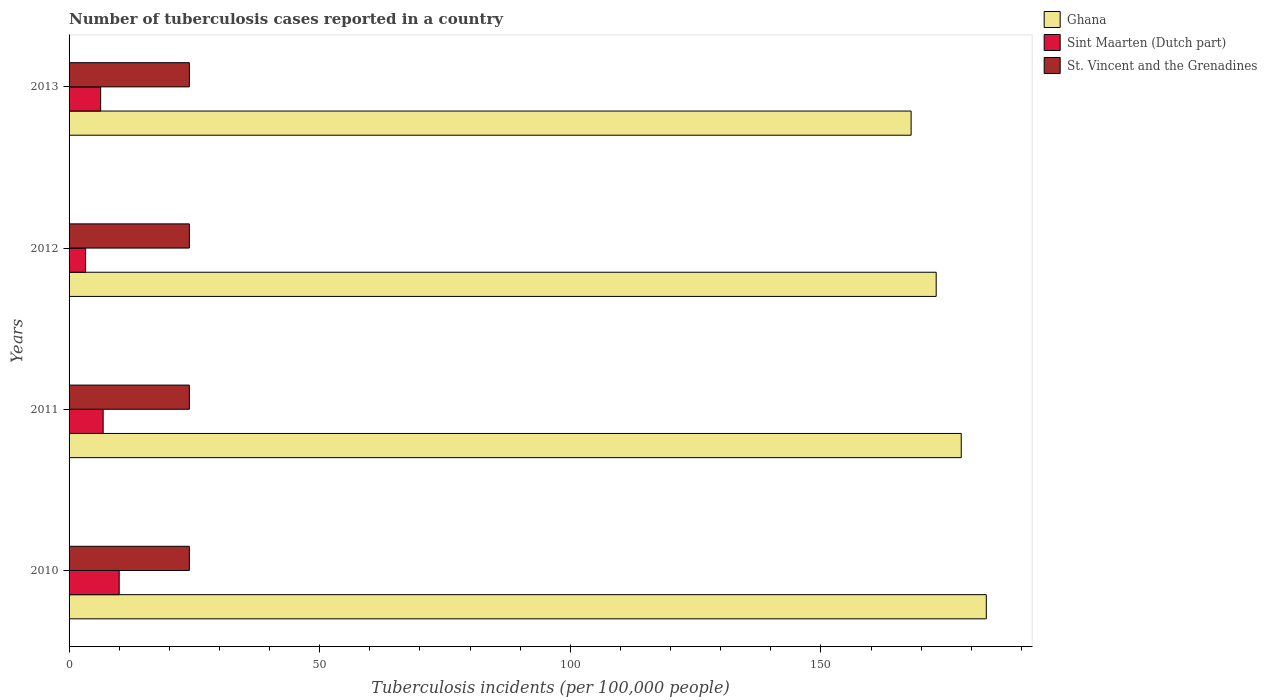How many bars are there on the 2nd tick from the top?
Make the answer very short. 3. What is the label of the 2nd group of bars from the top?
Give a very brief answer. 2012. In how many cases, is the number of bars for a given year not equal to the number of legend labels?
Give a very brief answer. 0. What is the number of tuberculosis cases reported in in Ghana in 2013?
Offer a very short reply. 168. Across all years, what is the maximum number of tuberculosis cases reported in in Ghana?
Your response must be concise. 183. In which year was the number of tuberculosis cases reported in in Sint Maarten (Dutch part) maximum?
Provide a short and direct response. 2010. What is the total number of tuberculosis cases reported in in Sint Maarten (Dutch part) in the graph?
Your answer should be very brief. 26.4. What is the difference between the number of tuberculosis cases reported in in Sint Maarten (Dutch part) in 2011 and that in 2013?
Give a very brief answer. 0.5. What is the difference between the number of tuberculosis cases reported in in Sint Maarten (Dutch part) in 2011 and the number of tuberculosis cases reported in in Ghana in 2013?
Your response must be concise. -161.2. What is the average number of tuberculosis cases reported in in Sint Maarten (Dutch part) per year?
Give a very brief answer. 6.6. In the year 2013, what is the difference between the number of tuberculosis cases reported in in St. Vincent and the Grenadines and number of tuberculosis cases reported in in Ghana?
Keep it short and to the point. -144. What is the difference between the highest and the second highest number of tuberculosis cases reported in in Sint Maarten (Dutch part)?
Give a very brief answer. 3.2. What is the difference between the highest and the lowest number of tuberculosis cases reported in in Sint Maarten (Dutch part)?
Provide a succinct answer. 6.7. In how many years, is the number of tuberculosis cases reported in in Ghana greater than the average number of tuberculosis cases reported in in Ghana taken over all years?
Offer a terse response. 2. What does the 1st bar from the top in 2012 represents?
Provide a succinct answer. St. Vincent and the Grenadines. What does the 1st bar from the bottom in 2010 represents?
Give a very brief answer. Ghana. Is it the case that in every year, the sum of the number of tuberculosis cases reported in in Sint Maarten (Dutch part) and number of tuberculosis cases reported in in St. Vincent and the Grenadines is greater than the number of tuberculosis cases reported in in Ghana?
Your answer should be very brief. No. Are all the bars in the graph horizontal?
Your answer should be very brief. Yes. What is the difference between two consecutive major ticks on the X-axis?
Make the answer very short. 50. Are the values on the major ticks of X-axis written in scientific E-notation?
Keep it short and to the point. No. Does the graph contain grids?
Your answer should be very brief. No. Where does the legend appear in the graph?
Provide a succinct answer. Top right. What is the title of the graph?
Your answer should be very brief. Number of tuberculosis cases reported in a country. What is the label or title of the X-axis?
Your response must be concise. Tuberculosis incidents (per 100,0 people). What is the Tuberculosis incidents (per 100,000 people) in Ghana in 2010?
Your answer should be very brief. 183. What is the Tuberculosis incidents (per 100,000 people) of Sint Maarten (Dutch part) in 2010?
Your response must be concise. 10. What is the Tuberculosis incidents (per 100,000 people) in St. Vincent and the Grenadines in 2010?
Give a very brief answer. 24. What is the Tuberculosis incidents (per 100,000 people) in Ghana in 2011?
Make the answer very short. 178. What is the Tuberculosis incidents (per 100,000 people) of Sint Maarten (Dutch part) in 2011?
Your response must be concise. 6.8. What is the Tuberculosis incidents (per 100,000 people) in St. Vincent and the Grenadines in 2011?
Your answer should be very brief. 24. What is the Tuberculosis incidents (per 100,000 people) in Ghana in 2012?
Your response must be concise. 173. What is the Tuberculosis incidents (per 100,000 people) in Ghana in 2013?
Provide a short and direct response. 168. What is the Tuberculosis incidents (per 100,000 people) in Sint Maarten (Dutch part) in 2013?
Keep it short and to the point. 6.3. Across all years, what is the maximum Tuberculosis incidents (per 100,000 people) of Ghana?
Your answer should be very brief. 183. Across all years, what is the minimum Tuberculosis incidents (per 100,000 people) in Ghana?
Keep it short and to the point. 168. Across all years, what is the minimum Tuberculosis incidents (per 100,000 people) in St. Vincent and the Grenadines?
Keep it short and to the point. 24. What is the total Tuberculosis incidents (per 100,000 people) in Ghana in the graph?
Ensure brevity in your answer.  702. What is the total Tuberculosis incidents (per 100,000 people) in Sint Maarten (Dutch part) in the graph?
Ensure brevity in your answer.  26.4. What is the total Tuberculosis incidents (per 100,000 people) in St. Vincent and the Grenadines in the graph?
Provide a short and direct response. 96. What is the difference between the Tuberculosis incidents (per 100,000 people) of Ghana in 2010 and that in 2011?
Make the answer very short. 5. What is the difference between the Tuberculosis incidents (per 100,000 people) of Sint Maarten (Dutch part) in 2010 and that in 2011?
Make the answer very short. 3.2. What is the difference between the Tuberculosis incidents (per 100,000 people) of St. Vincent and the Grenadines in 2010 and that in 2011?
Make the answer very short. 0. What is the difference between the Tuberculosis incidents (per 100,000 people) of St. Vincent and the Grenadines in 2010 and that in 2012?
Keep it short and to the point. 0. What is the difference between the Tuberculosis incidents (per 100,000 people) of Ghana in 2010 and that in 2013?
Offer a very short reply. 15. What is the difference between the Tuberculosis incidents (per 100,000 people) of Sint Maarten (Dutch part) in 2010 and that in 2013?
Keep it short and to the point. 3.7. What is the difference between the Tuberculosis incidents (per 100,000 people) in St. Vincent and the Grenadines in 2010 and that in 2013?
Provide a succinct answer. 0. What is the difference between the Tuberculosis incidents (per 100,000 people) in Ghana in 2011 and that in 2012?
Keep it short and to the point. 5. What is the difference between the Tuberculosis incidents (per 100,000 people) in St. Vincent and the Grenadines in 2011 and that in 2012?
Your response must be concise. 0. What is the difference between the Tuberculosis incidents (per 100,000 people) in Ghana in 2011 and that in 2013?
Provide a succinct answer. 10. What is the difference between the Tuberculosis incidents (per 100,000 people) in Sint Maarten (Dutch part) in 2011 and that in 2013?
Your response must be concise. 0.5. What is the difference between the Tuberculosis incidents (per 100,000 people) in Sint Maarten (Dutch part) in 2012 and that in 2013?
Offer a very short reply. -3. What is the difference between the Tuberculosis incidents (per 100,000 people) of St. Vincent and the Grenadines in 2012 and that in 2013?
Your response must be concise. 0. What is the difference between the Tuberculosis incidents (per 100,000 people) of Ghana in 2010 and the Tuberculosis incidents (per 100,000 people) of Sint Maarten (Dutch part) in 2011?
Your answer should be very brief. 176.2. What is the difference between the Tuberculosis incidents (per 100,000 people) in Ghana in 2010 and the Tuberculosis incidents (per 100,000 people) in St. Vincent and the Grenadines in 2011?
Offer a terse response. 159. What is the difference between the Tuberculosis incidents (per 100,000 people) of Ghana in 2010 and the Tuberculosis incidents (per 100,000 people) of Sint Maarten (Dutch part) in 2012?
Provide a succinct answer. 179.7. What is the difference between the Tuberculosis incidents (per 100,000 people) in Ghana in 2010 and the Tuberculosis incidents (per 100,000 people) in St. Vincent and the Grenadines in 2012?
Ensure brevity in your answer.  159. What is the difference between the Tuberculosis incidents (per 100,000 people) in Sint Maarten (Dutch part) in 2010 and the Tuberculosis incidents (per 100,000 people) in St. Vincent and the Grenadines in 2012?
Give a very brief answer. -14. What is the difference between the Tuberculosis incidents (per 100,000 people) of Ghana in 2010 and the Tuberculosis incidents (per 100,000 people) of Sint Maarten (Dutch part) in 2013?
Ensure brevity in your answer.  176.7. What is the difference between the Tuberculosis incidents (per 100,000 people) in Ghana in 2010 and the Tuberculosis incidents (per 100,000 people) in St. Vincent and the Grenadines in 2013?
Make the answer very short. 159. What is the difference between the Tuberculosis incidents (per 100,000 people) in Sint Maarten (Dutch part) in 2010 and the Tuberculosis incidents (per 100,000 people) in St. Vincent and the Grenadines in 2013?
Provide a succinct answer. -14. What is the difference between the Tuberculosis incidents (per 100,000 people) of Ghana in 2011 and the Tuberculosis incidents (per 100,000 people) of Sint Maarten (Dutch part) in 2012?
Offer a very short reply. 174.7. What is the difference between the Tuberculosis incidents (per 100,000 people) in Ghana in 2011 and the Tuberculosis incidents (per 100,000 people) in St. Vincent and the Grenadines in 2012?
Offer a terse response. 154. What is the difference between the Tuberculosis incidents (per 100,000 people) in Sint Maarten (Dutch part) in 2011 and the Tuberculosis incidents (per 100,000 people) in St. Vincent and the Grenadines in 2012?
Offer a terse response. -17.2. What is the difference between the Tuberculosis incidents (per 100,000 people) of Ghana in 2011 and the Tuberculosis incidents (per 100,000 people) of Sint Maarten (Dutch part) in 2013?
Make the answer very short. 171.7. What is the difference between the Tuberculosis incidents (per 100,000 people) in Ghana in 2011 and the Tuberculosis incidents (per 100,000 people) in St. Vincent and the Grenadines in 2013?
Provide a short and direct response. 154. What is the difference between the Tuberculosis incidents (per 100,000 people) in Sint Maarten (Dutch part) in 2011 and the Tuberculosis incidents (per 100,000 people) in St. Vincent and the Grenadines in 2013?
Keep it short and to the point. -17.2. What is the difference between the Tuberculosis incidents (per 100,000 people) of Ghana in 2012 and the Tuberculosis incidents (per 100,000 people) of Sint Maarten (Dutch part) in 2013?
Offer a very short reply. 166.7. What is the difference between the Tuberculosis incidents (per 100,000 people) in Ghana in 2012 and the Tuberculosis incidents (per 100,000 people) in St. Vincent and the Grenadines in 2013?
Offer a very short reply. 149. What is the difference between the Tuberculosis incidents (per 100,000 people) in Sint Maarten (Dutch part) in 2012 and the Tuberculosis incidents (per 100,000 people) in St. Vincent and the Grenadines in 2013?
Offer a very short reply. -20.7. What is the average Tuberculosis incidents (per 100,000 people) in Ghana per year?
Keep it short and to the point. 175.5. What is the average Tuberculosis incidents (per 100,000 people) in Sint Maarten (Dutch part) per year?
Your response must be concise. 6.6. What is the average Tuberculosis incidents (per 100,000 people) in St. Vincent and the Grenadines per year?
Provide a short and direct response. 24. In the year 2010, what is the difference between the Tuberculosis incidents (per 100,000 people) of Ghana and Tuberculosis incidents (per 100,000 people) of Sint Maarten (Dutch part)?
Offer a very short reply. 173. In the year 2010, what is the difference between the Tuberculosis incidents (per 100,000 people) of Ghana and Tuberculosis incidents (per 100,000 people) of St. Vincent and the Grenadines?
Ensure brevity in your answer.  159. In the year 2011, what is the difference between the Tuberculosis incidents (per 100,000 people) in Ghana and Tuberculosis incidents (per 100,000 people) in Sint Maarten (Dutch part)?
Provide a succinct answer. 171.2. In the year 2011, what is the difference between the Tuberculosis incidents (per 100,000 people) of Ghana and Tuberculosis incidents (per 100,000 people) of St. Vincent and the Grenadines?
Ensure brevity in your answer.  154. In the year 2011, what is the difference between the Tuberculosis incidents (per 100,000 people) of Sint Maarten (Dutch part) and Tuberculosis incidents (per 100,000 people) of St. Vincent and the Grenadines?
Ensure brevity in your answer.  -17.2. In the year 2012, what is the difference between the Tuberculosis incidents (per 100,000 people) of Ghana and Tuberculosis incidents (per 100,000 people) of Sint Maarten (Dutch part)?
Your answer should be compact. 169.7. In the year 2012, what is the difference between the Tuberculosis incidents (per 100,000 people) of Ghana and Tuberculosis incidents (per 100,000 people) of St. Vincent and the Grenadines?
Provide a short and direct response. 149. In the year 2012, what is the difference between the Tuberculosis incidents (per 100,000 people) of Sint Maarten (Dutch part) and Tuberculosis incidents (per 100,000 people) of St. Vincent and the Grenadines?
Your answer should be compact. -20.7. In the year 2013, what is the difference between the Tuberculosis incidents (per 100,000 people) in Ghana and Tuberculosis incidents (per 100,000 people) in Sint Maarten (Dutch part)?
Provide a succinct answer. 161.7. In the year 2013, what is the difference between the Tuberculosis incidents (per 100,000 people) of Ghana and Tuberculosis incidents (per 100,000 people) of St. Vincent and the Grenadines?
Offer a very short reply. 144. In the year 2013, what is the difference between the Tuberculosis incidents (per 100,000 people) of Sint Maarten (Dutch part) and Tuberculosis incidents (per 100,000 people) of St. Vincent and the Grenadines?
Your answer should be very brief. -17.7. What is the ratio of the Tuberculosis incidents (per 100,000 people) of Ghana in 2010 to that in 2011?
Give a very brief answer. 1.03. What is the ratio of the Tuberculosis incidents (per 100,000 people) of Sint Maarten (Dutch part) in 2010 to that in 2011?
Provide a short and direct response. 1.47. What is the ratio of the Tuberculosis incidents (per 100,000 people) in Ghana in 2010 to that in 2012?
Ensure brevity in your answer.  1.06. What is the ratio of the Tuberculosis incidents (per 100,000 people) of Sint Maarten (Dutch part) in 2010 to that in 2012?
Ensure brevity in your answer.  3.03. What is the ratio of the Tuberculosis incidents (per 100,000 people) of St. Vincent and the Grenadines in 2010 to that in 2012?
Your response must be concise. 1. What is the ratio of the Tuberculosis incidents (per 100,000 people) of Ghana in 2010 to that in 2013?
Give a very brief answer. 1.09. What is the ratio of the Tuberculosis incidents (per 100,000 people) in Sint Maarten (Dutch part) in 2010 to that in 2013?
Your answer should be compact. 1.59. What is the ratio of the Tuberculosis incidents (per 100,000 people) in St. Vincent and the Grenadines in 2010 to that in 2013?
Your answer should be compact. 1. What is the ratio of the Tuberculosis incidents (per 100,000 people) in Ghana in 2011 to that in 2012?
Your answer should be very brief. 1.03. What is the ratio of the Tuberculosis incidents (per 100,000 people) of Sint Maarten (Dutch part) in 2011 to that in 2012?
Your response must be concise. 2.06. What is the ratio of the Tuberculosis incidents (per 100,000 people) in St. Vincent and the Grenadines in 2011 to that in 2012?
Offer a very short reply. 1. What is the ratio of the Tuberculosis incidents (per 100,000 people) of Ghana in 2011 to that in 2013?
Ensure brevity in your answer.  1.06. What is the ratio of the Tuberculosis incidents (per 100,000 people) of Sint Maarten (Dutch part) in 2011 to that in 2013?
Give a very brief answer. 1.08. What is the ratio of the Tuberculosis incidents (per 100,000 people) in St. Vincent and the Grenadines in 2011 to that in 2013?
Provide a short and direct response. 1. What is the ratio of the Tuberculosis incidents (per 100,000 people) in Ghana in 2012 to that in 2013?
Offer a terse response. 1.03. What is the ratio of the Tuberculosis incidents (per 100,000 people) of Sint Maarten (Dutch part) in 2012 to that in 2013?
Ensure brevity in your answer.  0.52. What is the difference between the highest and the lowest Tuberculosis incidents (per 100,000 people) of Ghana?
Offer a terse response. 15. 